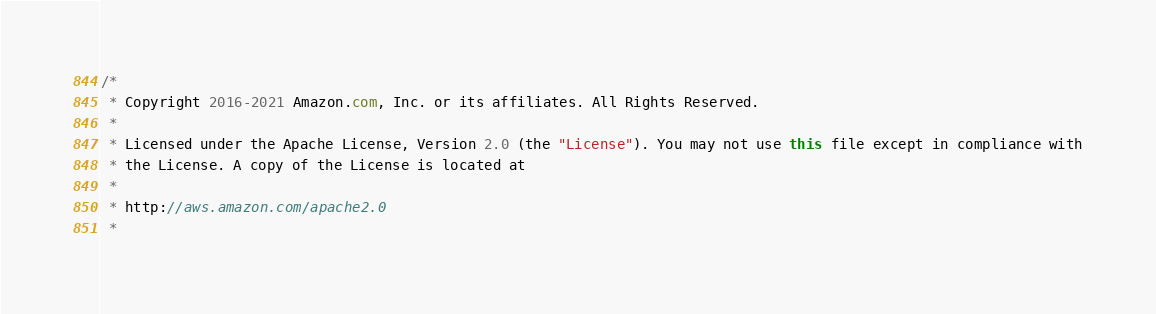<code> <loc_0><loc_0><loc_500><loc_500><_Java_>/*
 * Copyright 2016-2021 Amazon.com, Inc. or its affiliates. All Rights Reserved.
 * 
 * Licensed under the Apache License, Version 2.0 (the "License"). You may not use this file except in compliance with
 * the License. A copy of the License is located at
 * 
 * http://aws.amazon.com/apache2.0
 * </code> 